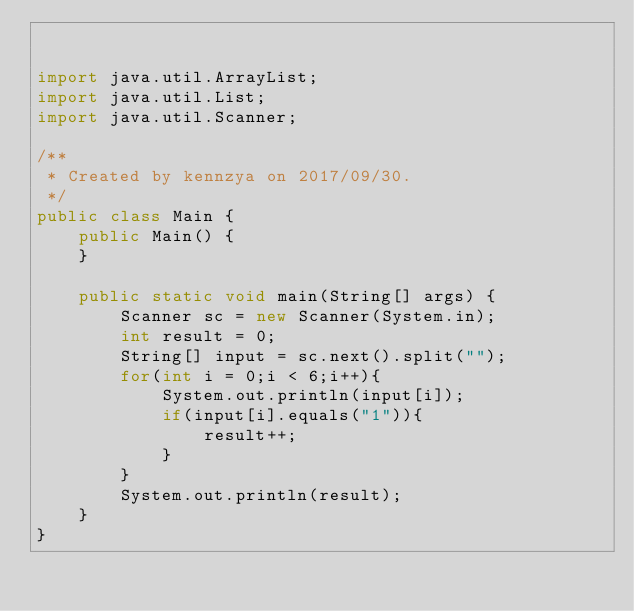Convert code to text. <code><loc_0><loc_0><loc_500><loc_500><_Java_>

import java.util.ArrayList;
import java.util.List;
import java.util.Scanner;

/**
 * Created by kennzya on 2017/09/30.
 */
public class Main {
    public Main() {
    }

    public static void main(String[] args) {
        Scanner sc = new Scanner(System.in);
        int result = 0;
        String[] input = sc.next().split("");
        for(int i = 0;i < 6;i++){
            System.out.println(input[i]);
            if(input[i].equals("1")){
                result++;
            }
        }
        System.out.println(result);
    }
}
</code> 